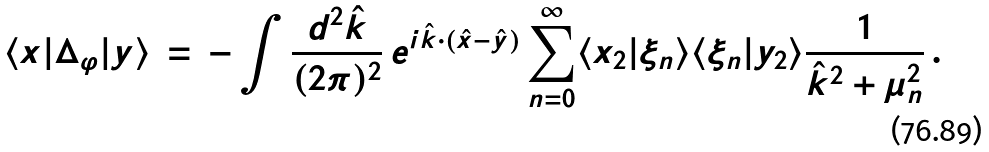Convert formula to latex. <formula><loc_0><loc_0><loc_500><loc_500>\langle x | \Delta _ { \varphi } | y \rangle \, = \, - \int \frac { d ^ { 2 } { \hat { k } } } { ( 2 \pi ) ^ { 2 } } \, e ^ { i { \hat { k } } \cdot ( { \hat { x } } - { \hat { y } } ) } \sum _ { n = 0 } ^ { \infty } \langle x _ { 2 } | \xi _ { n } \rangle \langle \xi _ { n } | y _ { 2 } \rangle \frac { 1 } { { \hat { k } } ^ { 2 } + \mu _ { n } ^ { 2 } } \, .</formula> 